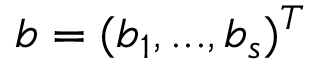Convert formula to latex. <formula><loc_0><loc_0><loc_500><loc_500>b = ( b _ { 1 } , \dots , b _ { s } ) ^ { T }</formula> 